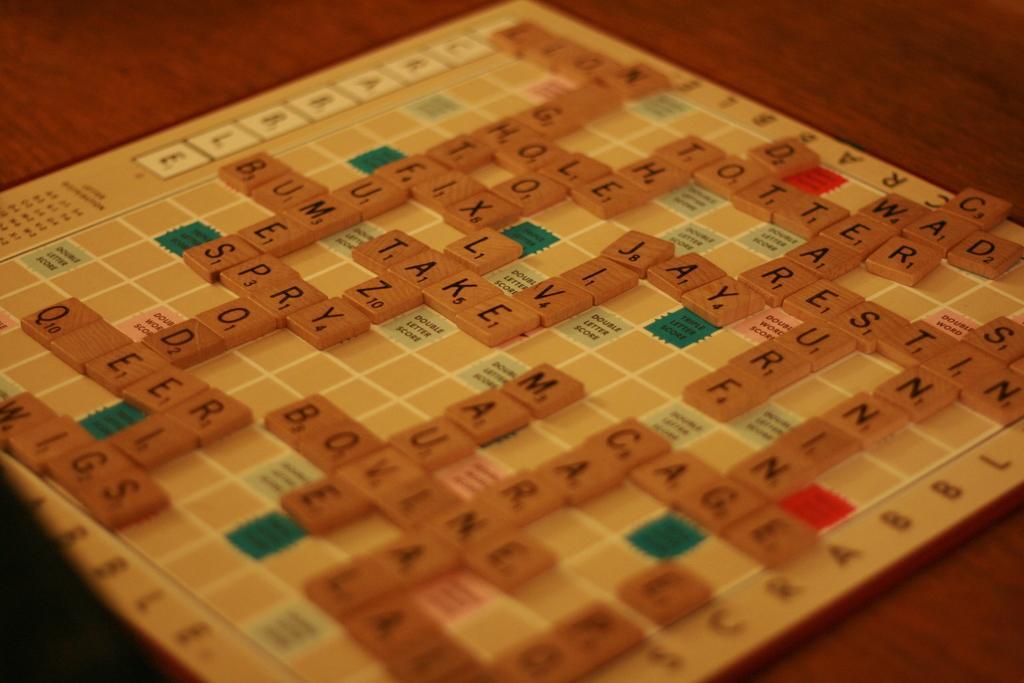Can you describe this image briefly? In the image we can see there is a word puzzle board kept on the table and there are words arranged on the puzzle board. 